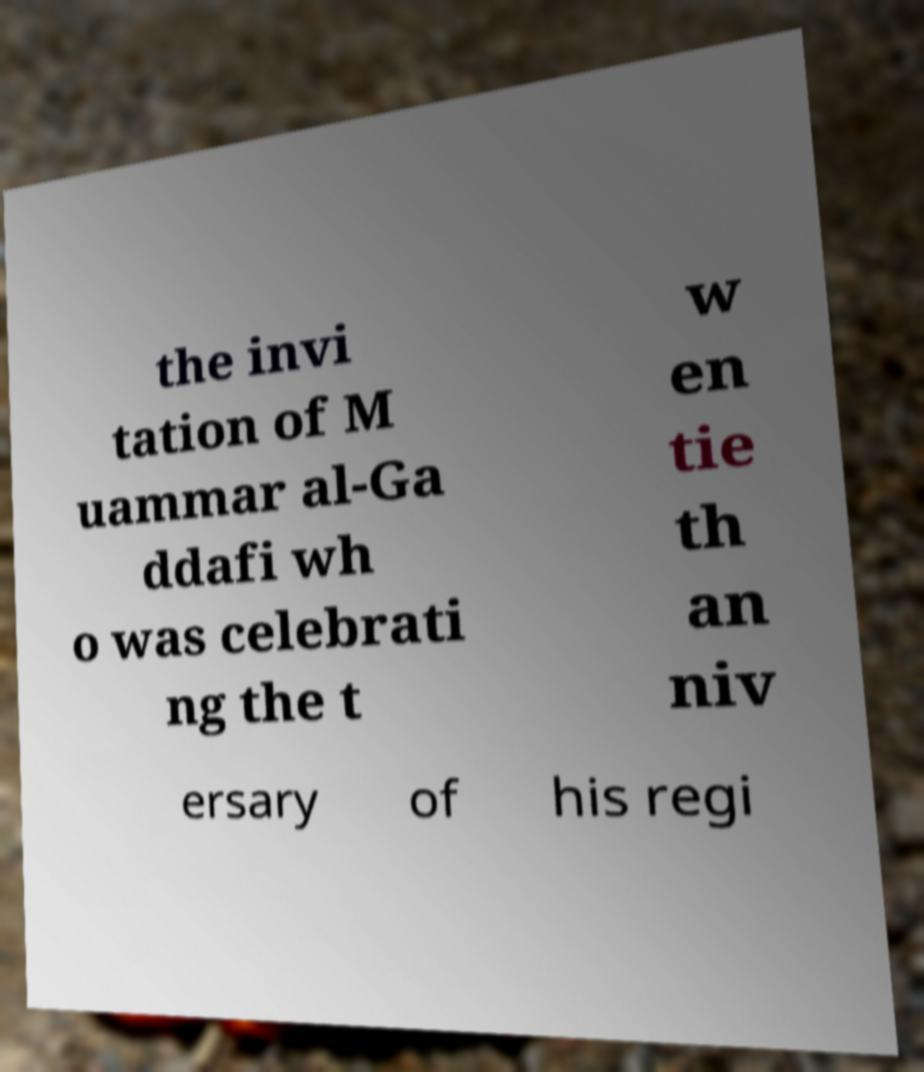Can you accurately transcribe the text from the provided image for me? the invi tation of M uammar al-Ga ddafi wh o was celebrati ng the t w en tie th an niv ersary of his regi 